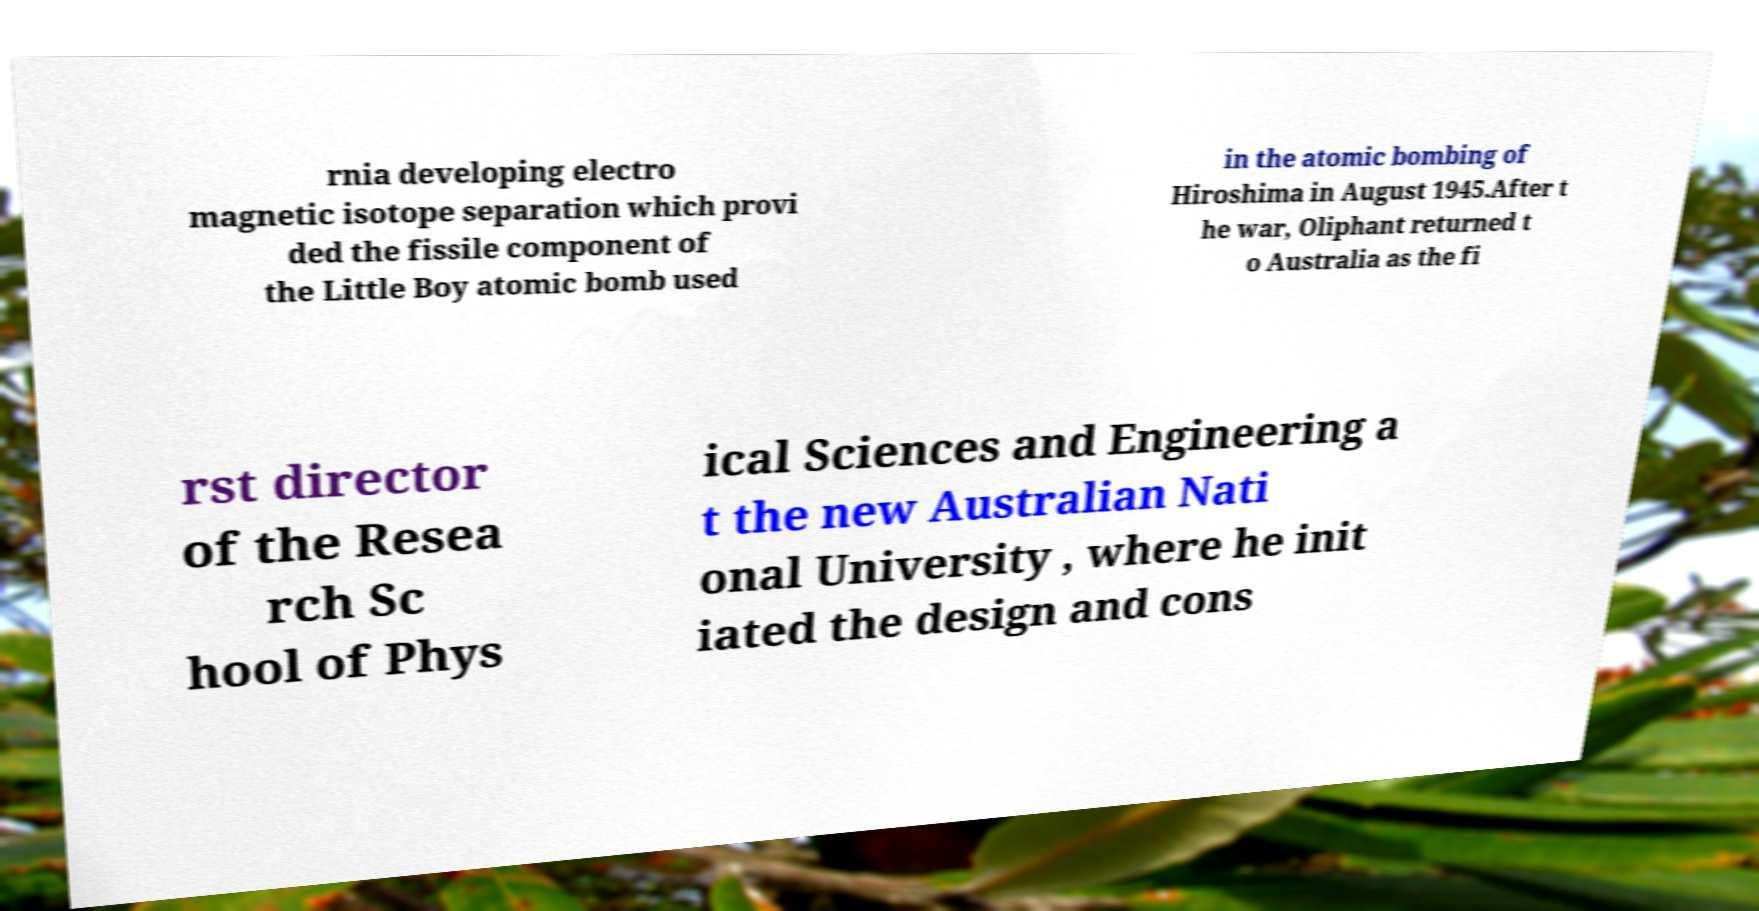Can you read and provide the text displayed in the image?This photo seems to have some interesting text. Can you extract and type it out for me? rnia developing electro magnetic isotope separation which provi ded the fissile component of the Little Boy atomic bomb used in the atomic bombing of Hiroshima in August 1945.After t he war, Oliphant returned t o Australia as the fi rst director of the Resea rch Sc hool of Phys ical Sciences and Engineering a t the new Australian Nati onal University , where he init iated the design and cons 